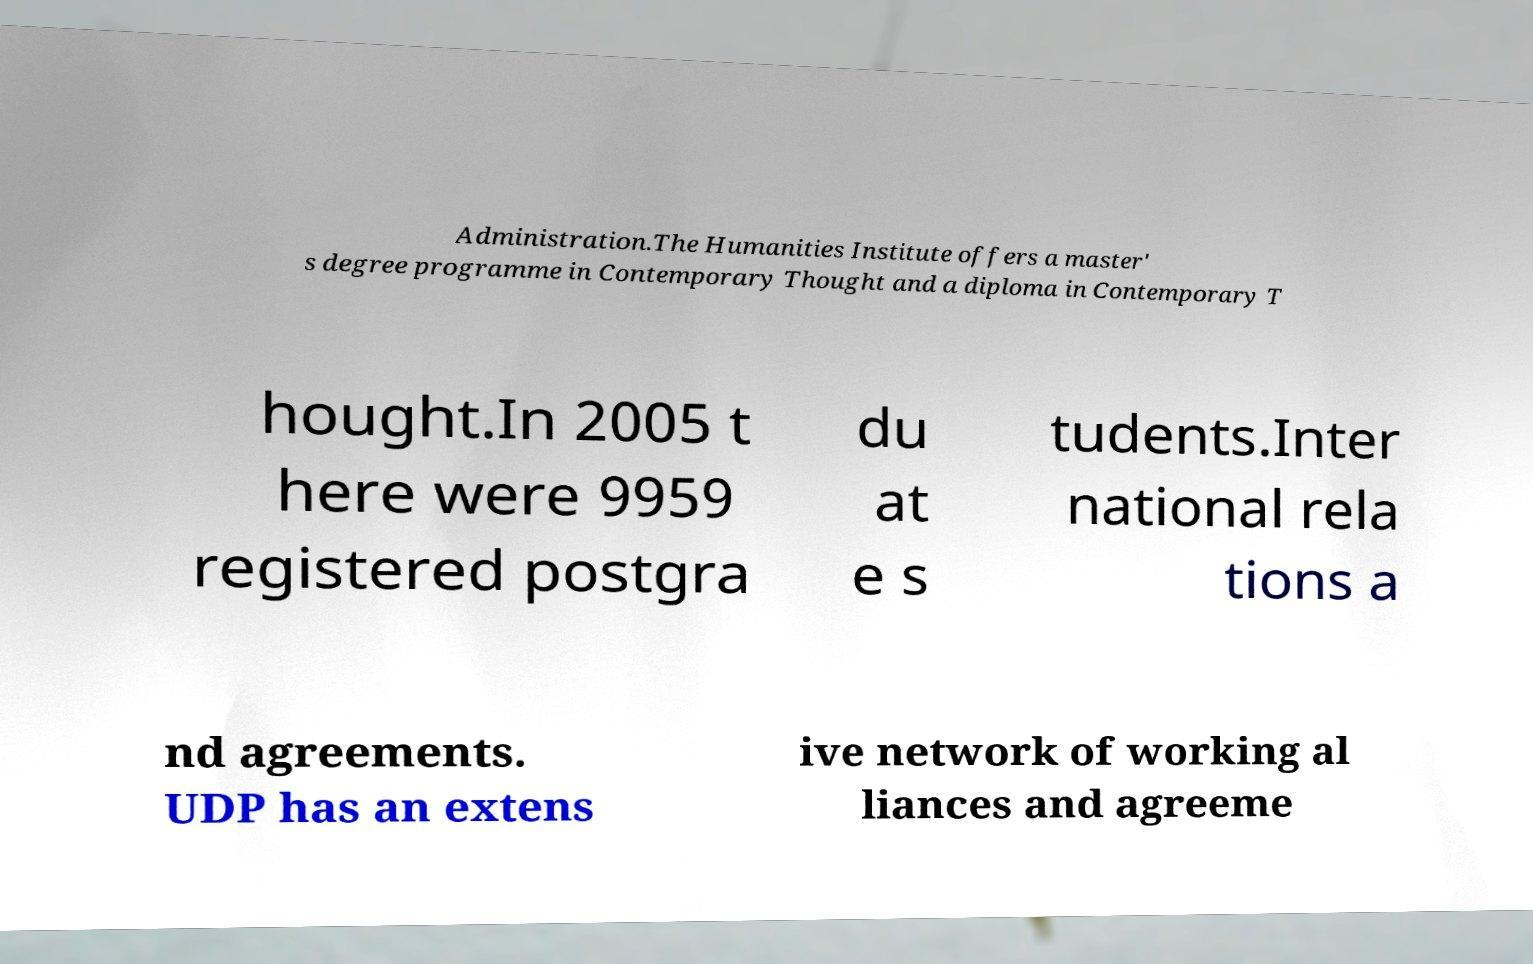I need the written content from this picture converted into text. Can you do that? Administration.The Humanities Institute offers a master' s degree programme in Contemporary Thought and a diploma in Contemporary T hought.In 2005 t here were 9959 registered postgra du at e s tudents.Inter national rela tions a nd agreements. UDP has an extens ive network of working al liances and agreeme 